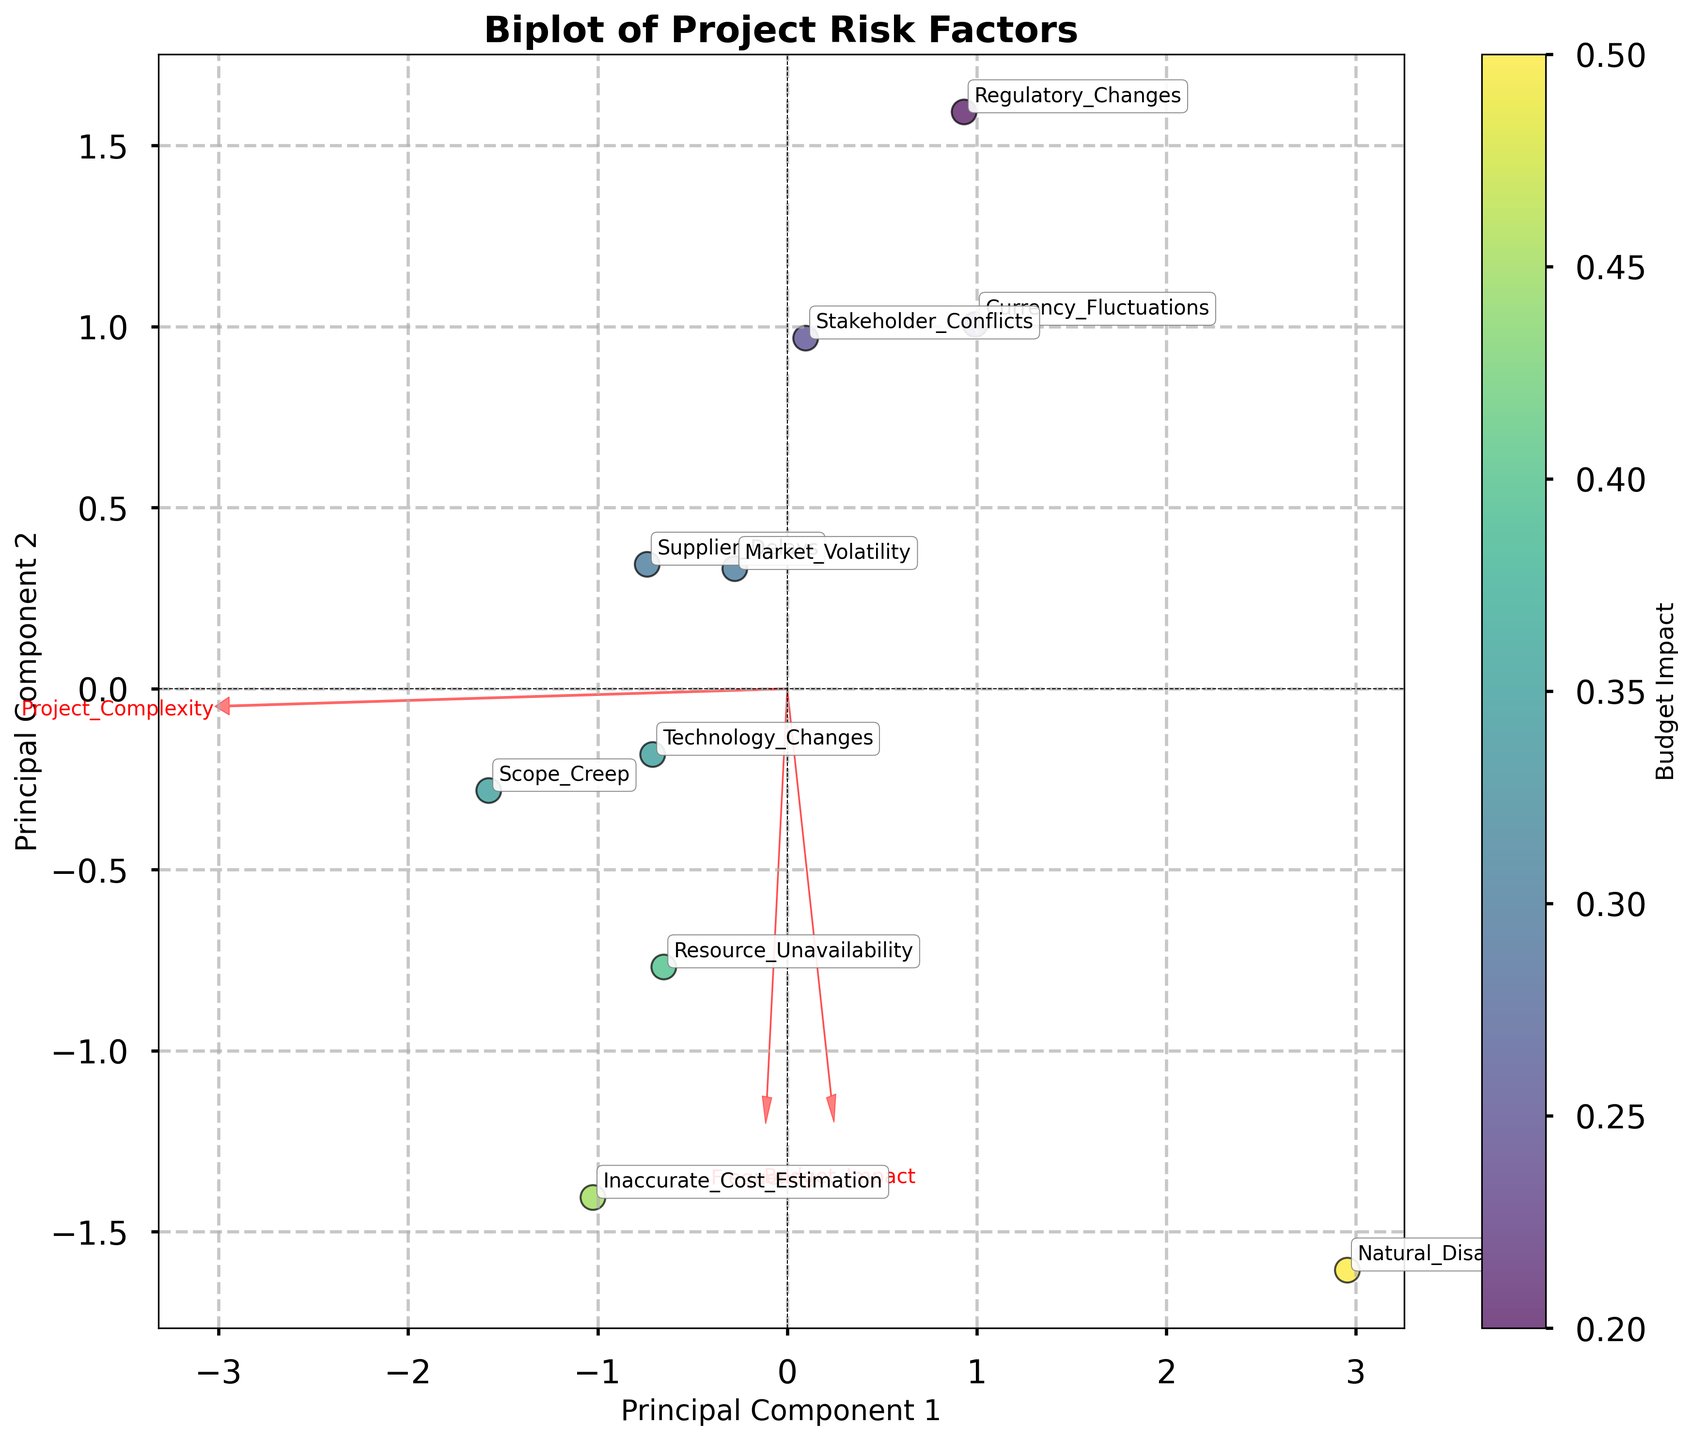What is the title of the plot? The title is located at the top of the plot and is typically used to describe the overall purpose or subject of the visual representation. In this case, it is likely to be a phrase summarizing the plot's focus on risk factors and their impact on project budgets.
Answer: Biplot of Project Risk Factors What do the x-axis and y-axis represent in the plot? The labels on the x-axis and y-axis provide information on the dimensions used for plotting, which in a biplot usually refer to the first and second principal components derived from the data. These components summarize the variance in the data.
Answer: Principal Component 1 and Principal Component 2 Which risk factor has the highest Budget Impact? Each point in the biplot is associated with a specific risk factor and its position is colored based on Budget Impact. The color gradient (e.g., moving from lighter to darker) indicates the magnitude of the impact. The legend or color bar helps identify the risk factor with the highest impact.
Answer: Natural_Disasters What features are represented by the red arrows? Red arrows in a biplot usually indicate the original variables transformed to the principal component space. The annotated text at the end of each arrow helps in identifying which feature each arrow represents.
Answer: Budget_Impact, Project_Complexity, Frequency Which risk factors are closest in terms of Principal Component 1 values? The proximity of data points along the x-axis (Principal Component 1) shows similarity in that dimension. Observing which points fall closely along this axis will reveal the risk factors with similar Principal Component 1 values.
Answer: Scope_Creep and Technology_Changes Which risk factor has the lowest frequency, and where is it located on the plot? The frequency can be identified through the annotations and potentially by looking at the red arrow indicating direction and magnitude of frequency variance. The location on the plot (relative lower y-axis placement) can also make low frequency identifiable.
Answer: Natural_Disasters; lower part of the plot How are Market Volatility and Regulatory Changes different in terms of Principal Component 2? By observing the positions of Market Volatility and Regulatory Changes along the y-axis, we can compare their values for Principal Component 2 and describe which one has a higher or lower value.
Answer: Market Volatility is higher on Principal Component 2 than Regulatory Changes What is the relationship between Project Complexity and Supplier Delays on the biplot? The direction and length of the red arrow for Project_Complexity compared with the position of the point for Supplier Delays can help determine the relationship. If the point is close to the arrow's direction, it indicates a positive association.
Answer: Positive association Which features contribute the most to Principal Component 1? The length and direction of the red arrows in the direction of Principal Component 1 help us see which original features have a strong influence on the first principal component. The feature with the longest arrow pointing in the direction of the PC1 axis has the greatest contribution.
Answer: Budget_Impact What clustering can be observed among the risk factors on the biplot? By visually examining groups of points that are closely clustered together on the plot, we can identify risk factors that exhibit similar characteristics across the principal components.
Answer: Clusters include Scope_Creep with Technology_Changes, Supplier_Delays with Resource_Unavailability 